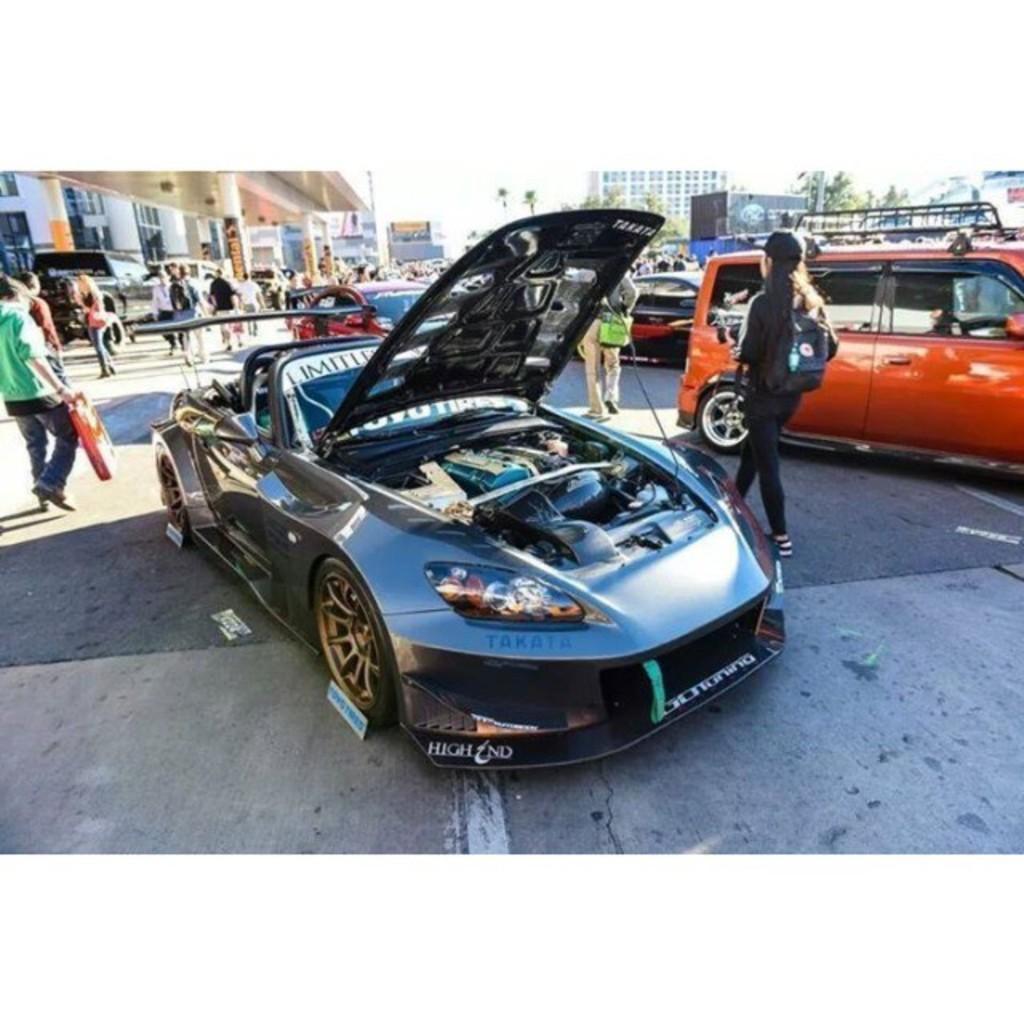How would you summarize this image in a sentence or two? In this image we can see few vehicles and people on the floor, in the background there are few buildings, tree and sky. 